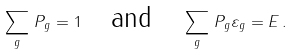Convert formula to latex. <formula><loc_0><loc_0><loc_500><loc_500>\sum _ { g } \, P _ { g } = 1 \quad \text {and} \quad \sum _ { g } \, P _ { g } \varepsilon _ { g } = E \, .</formula> 